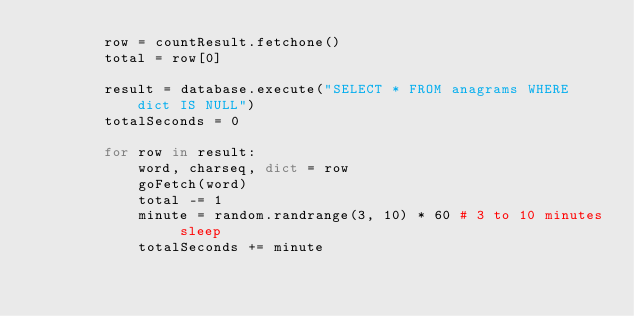Convert code to text. <code><loc_0><loc_0><loc_500><loc_500><_Python_>        row = countResult.fetchone()
        total = row[0]

        result = database.execute("SELECT * FROM anagrams WHERE dict IS NULL")
        totalSeconds = 0

        for row in result:
            word, charseq, dict = row
            goFetch(word)
            total -= 1
            minute = random.randrange(3, 10) * 60 # 3 to 10 minutes sleep
            totalSeconds += minute</code> 